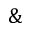Convert formula to latex. <formula><loc_0><loc_0><loc_500><loc_500>\&</formula> 